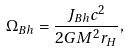Convert formula to latex. <formula><loc_0><loc_0><loc_500><loc_500>\Omega _ { B h } = \frac { J _ { B h } c ^ { 2 } } { 2 G M ^ { 2 } r _ { H } } ,</formula> 